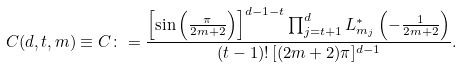Convert formula to latex. <formula><loc_0><loc_0><loc_500><loc_500>C ( d , t , m ) \equiv C \colon = \frac { \left [ \sin \left ( \frac { \pi } { 2 m + 2 } \right ) \right ] ^ { d - 1 - t } \prod _ { j = t + 1 } ^ { d } L _ { m _ { j } } ^ { * } \left ( - \frac { 1 } { 2 m + 2 } \right ) } { ( t - 1 ) ! \, [ ( 2 m + 2 ) \pi ] ^ { d - 1 } } .</formula> 